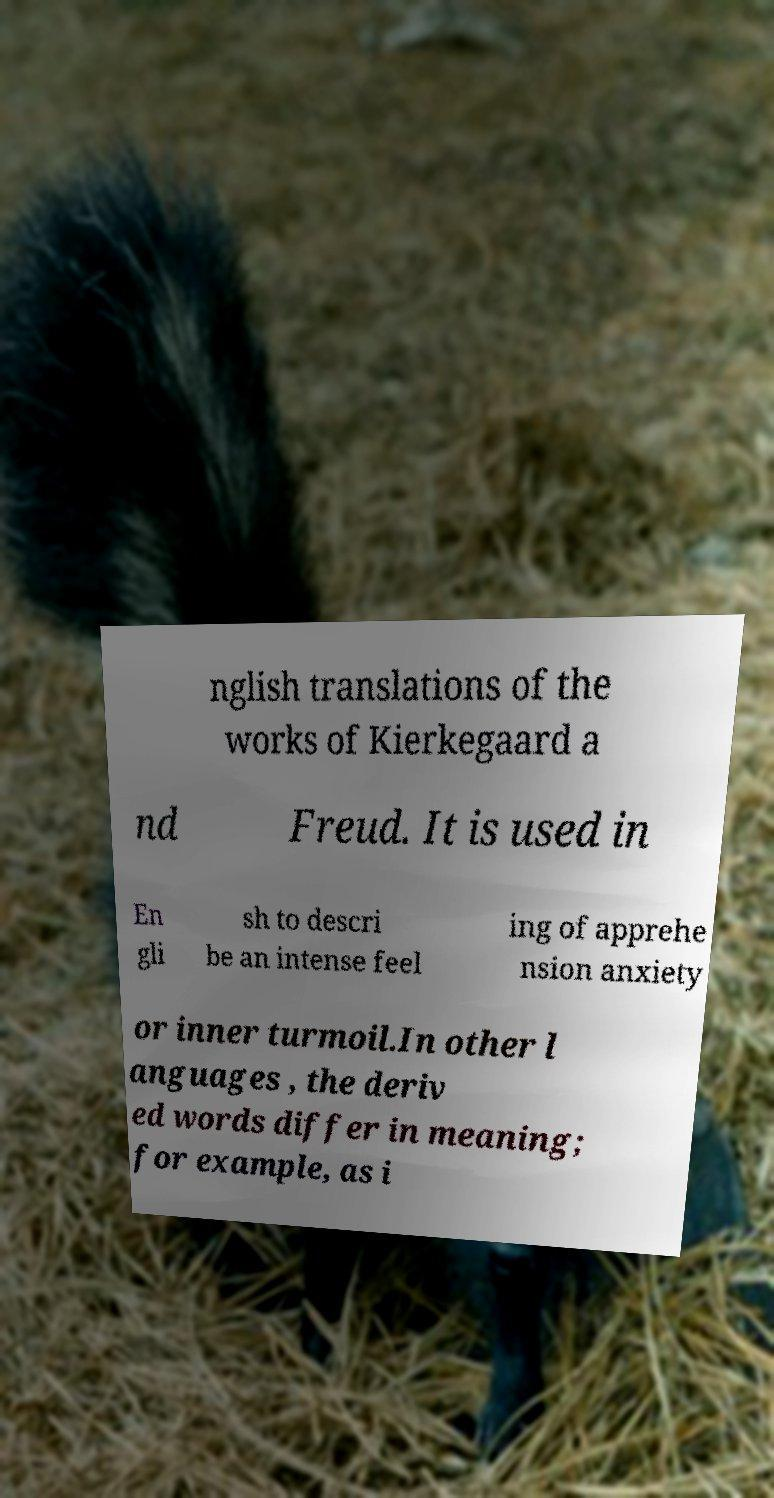Can you accurately transcribe the text from the provided image for me? nglish translations of the works of Kierkegaard a nd Freud. It is used in En gli sh to descri be an intense feel ing of apprehe nsion anxiety or inner turmoil.In other l anguages , the deriv ed words differ in meaning; for example, as i 